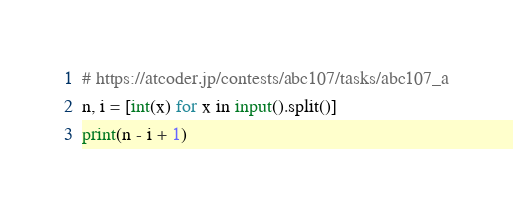<code> <loc_0><loc_0><loc_500><loc_500><_Python_># https://atcoder.jp/contests/abc107/tasks/abc107_a
n, i = [int(x) for x in input().split()]
print(n - i + 1)
</code> 